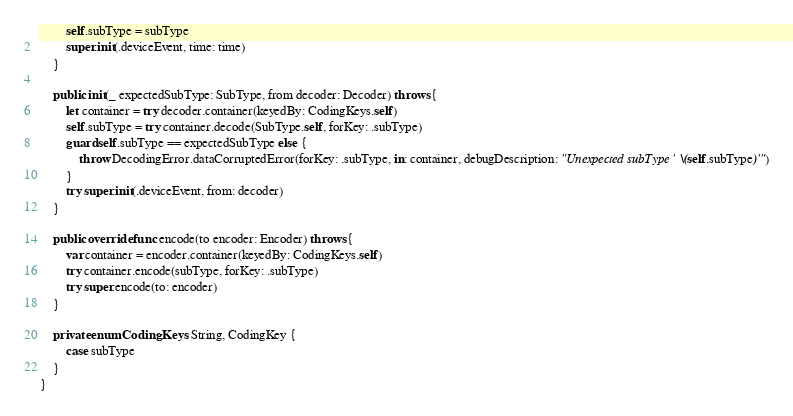<code> <loc_0><loc_0><loc_500><loc_500><_Swift_>        self.subType = subType
        super.init(.deviceEvent, time: time)
    }

    public init(_ expectedSubType: SubType, from decoder: Decoder) throws {
        let container = try decoder.container(keyedBy: CodingKeys.self)
        self.subType = try container.decode(SubType.self, forKey: .subType)
        guard self.subType == expectedSubType else {
            throw DecodingError.dataCorruptedError(forKey: .subType, in: container, debugDescription: "Unexpected subType '\(self.subType)'")
        }
        try super.init(.deviceEvent, from: decoder)
    }

    public override func encode(to encoder: Encoder) throws {
        var container = encoder.container(keyedBy: CodingKeys.self)
        try container.encode(subType, forKey: .subType)
        try super.encode(to: encoder)
    }

    private enum CodingKeys: String, CodingKey {
        case subType
    }
}
</code> 